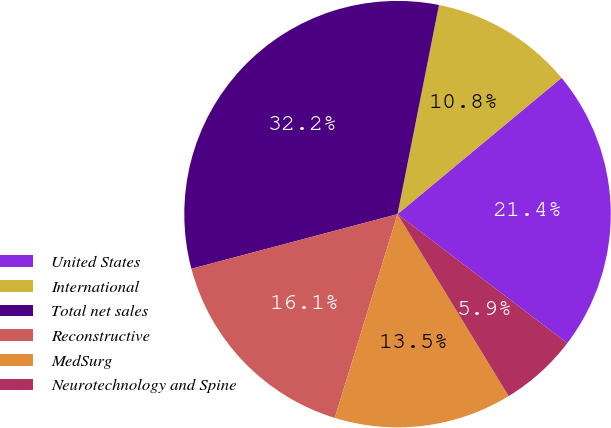<chart> <loc_0><loc_0><loc_500><loc_500><pie_chart><fcel>United States<fcel>International<fcel>Total net sales<fcel>Reconstructive<fcel>MedSurg<fcel>Neurotechnology and Spine<nl><fcel>21.38%<fcel>10.85%<fcel>32.24%<fcel>16.12%<fcel>13.48%<fcel>5.93%<nl></chart> 